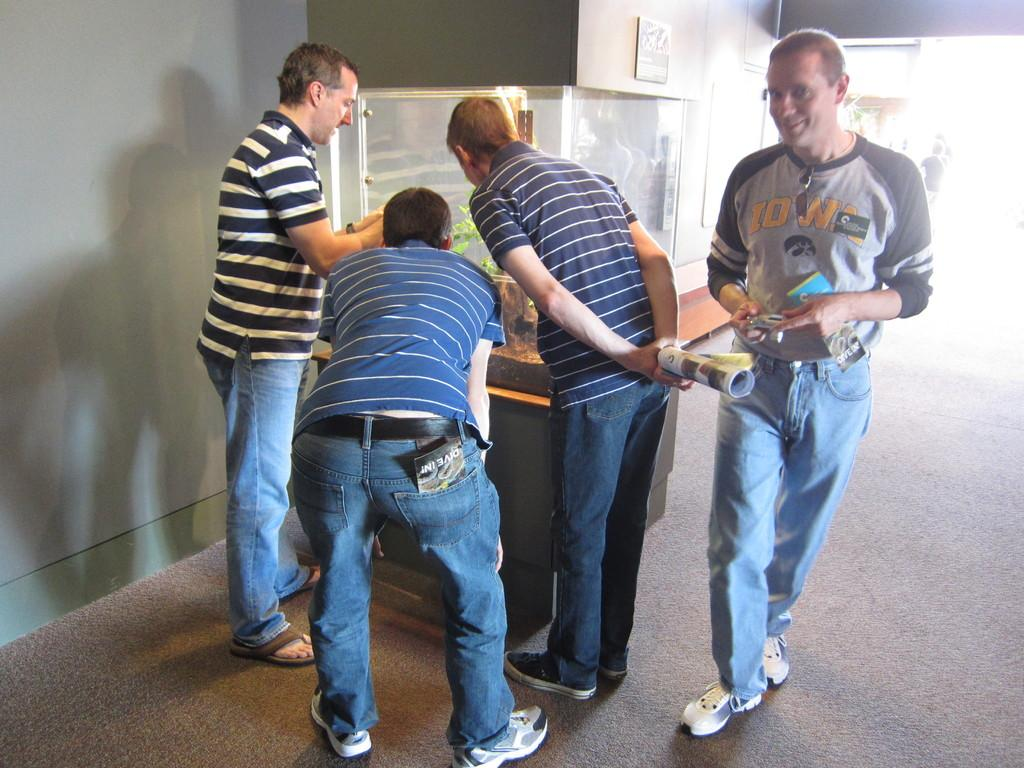What is happening in the image? There are people standing in the image. Can you describe the background of the image? There is a wall in the background of the image, on the left side. What type of page can be seen in the image? There is no page present in the image; it features people standing and a wall in the background. What sound can be heard coming from the cow in the image? There is no cow present in the image, so it is not possible to determine what sound might be heard. 